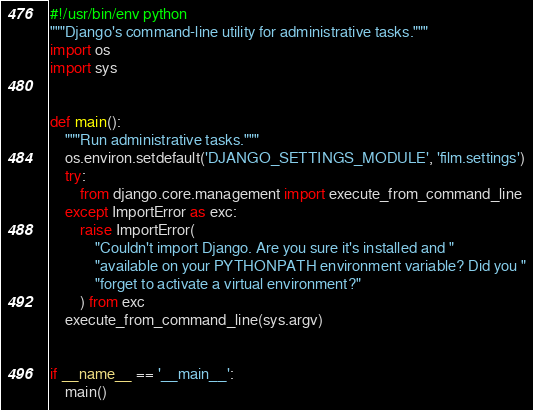Convert code to text. <code><loc_0><loc_0><loc_500><loc_500><_Python_>#!/usr/bin/env python
"""Django's command-line utility for administrative tasks."""
import os
import sys


def main():
    """Run administrative tasks."""
    os.environ.setdefault('DJANGO_SETTINGS_MODULE', 'film.settings')
    try:
        from django.core.management import execute_from_command_line
    except ImportError as exc:
        raise ImportError(
            "Couldn't import Django. Are you sure it's installed and "
            "available on your PYTHONPATH environment variable? Did you "
            "forget to activate a virtual environment?"
        ) from exc
    execute_from_command_line(sys.argv)


if __name__ == '__main__':
    main()
</code> 